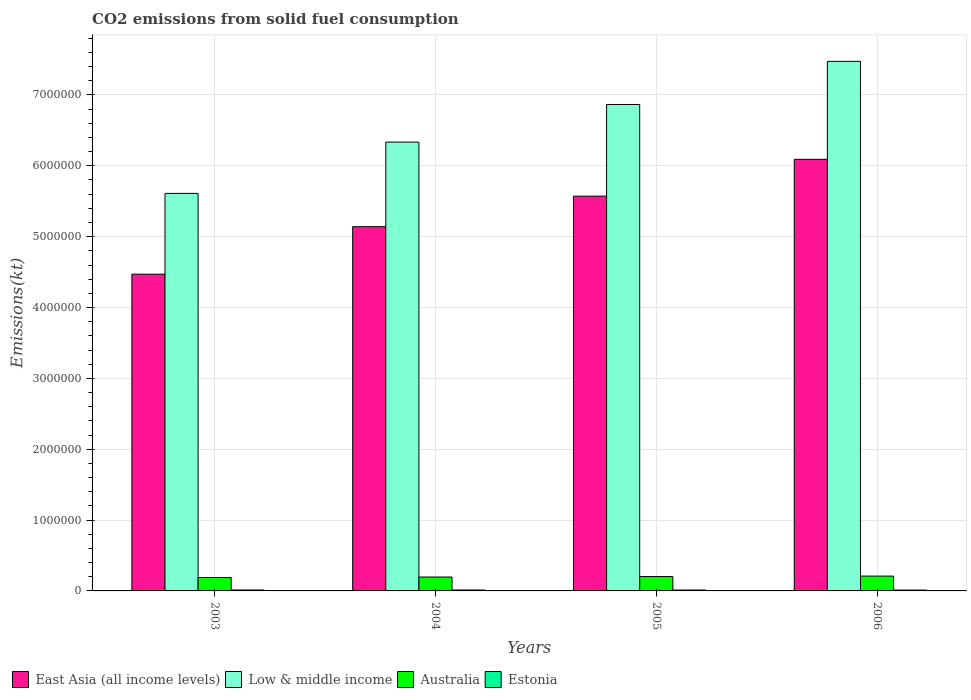How many groups of bars are there?
Your answer should be compact. 4. How many bars are there on the 1st tick from the left?
Offer a terse response. 4. How many bars are there on the 2nd tick from the right?
Make the answer very short. 4. What is the label of the 1st group of bars from the left?
Provide a succinct answer. 2003. What is the amount of CO2 emitted in East Asia (all income levels) in 2005?
Make the answer very short. 5.57e+06. Across all years, what is the maximum amount of CO2 emitted in Australia?
Provide a short and direct response. 2.09e+05. Across all years, what is the minimum amount of CO2 emitted in East Asia (all income levels)?
Offer a terse response. 4.47e+06. In which year was the amount of CO2 emitted in East Asia (all income levels) minimum?
Keep it short and to the point. 2003. What is the total amount of CO2 emitted in Australia in the graph?
Provide a short and direct response. 7.98e+05. What is the difference between the amount of CO2 emitted in Estonia in 2004 and that in 2005?
Your answer should be compact. 498.71. What is the difference between the amount of CO2 emitted in Low & middle income in 2006 and the amount of CO2 emitted in Australia in 2004?
Offer a very short reply. 7.28e+06. What is the average amount of CO2 emitted in Australia per year?
Give a very brief answer. 2.00e+05. In the year 2005, what is the difference between the amount of CO2 emitted in Low & middle income and amount of CO2 emitted in East Asia (all income levels)?
Your answer should be compact. 1.29e+06. In how many years, is the amount of CO2 emitted in East Asia (all income levels) greater than 2400000 kt?
Your answer should be compact. 4. What is the ratio of the amount of CO2 emitted in Australia in 2003 to that in 2006?
Keep it short and to the point. 0.9. Is the amount of CO2 emitted in Estonia in 2003 less than that in 2004?
Provide a short and direct response. Yes. What is the difference between the highest and the second highest amount of CO2 emitted in Australia?
Provide a succinct answer. 6648.27. What is the difference between the highest and the lowest amount of CO2 emitted in Low & middle income?
Your answer should be very brief. 1.86e+06. In how many years, is the amount of CO2 emitted in East Asia (all income levels) greater than the average amount of CO2 emitted in East Asia (all income levels) taken over all years?
Ensure brevity in your answer.  2. What does the 4th bar from the left in 2005 represents?
Ensure brevity in your answer.  Estonia. What does the 4th bar from the right in 2006 represents?
Your response must be concise. East Asia (all income levels). Is it the case that in every year, the sum of the amount of CO2 emitted in East Asia (all income levels) and amount of CO2 emitted in Australia is greater than the amount of CO2 emitted in Estonia?
Provide a succinct answer. Yes. How many bars are there?
Your answer should be very brief. 16. Does the graph contain grids?
Your answer should be compact. Yes. Where does the legend appear in the graph?
Offer a terse response. Bottom left. What is the title of the graph?
Provide a succinct answer. CO2 emissions from solid fuel consumption. Does "Middle income" appear as one of the legend labels in the graph?
Provide a succinct answer. No. What is the label or title of the X-axis?
Give a very brief answer. Years. What is the label or title of the Y-axis?
Keep it short and to the point. Emissions(kt). What is the Emissions(kt) of East Asia (all income levels) in 2003?
Make the answer very short. 4.47e+06. What is the Emissions(kt) of Low & middle income in 2003?
Your answer should be compact. 5.61e+06. What is the Emissions(kt) in Australia in 2003?
Give a very brief answer. 1.90e+05. What is the Emissions(kt) of Estonia in 2003?
Ensure brevity in your answer.  1.31e+04. What is the Emissions(kt) in East Asia (all income levels) in 2004?
Your response must be concise. 5.14e+06. What is the Emissions(kt) of Low & middle income in 2004?
Make the answer very short. 6.33e+06. What is the Emissions(kt) in Australia in 2004?
Provide a short and direct response. 1.96e+05. What is the Emissions(kt) in Estonia in 2004?
Provide a succinct answer. 1.31e+04. What is the Emissions(kt) in East Asia (all income levels) in 2005?
Offer a very short reply. 5.57e+06. What is the Emissions(kt) of Low & middle income in 2005?
Keep it short and to the point. 6.87e+06. What is the Emissions(kt) in Australia in 2005?
Give a very brief answer. 2.03e+05. What is the Emissions(kt) of Estonia in 2005?
Keep it short and to the point. 1.26e+04. What is the Emissions(kt) in East Asia (all income levels) in 2006?
Your response must be concise. 6.09e+06. What is the Emissions(kt) in Low & middle income in 2006?
Offer a very short reply. 7.47e+06. What is the Emissions(kt) of Australia in 2006?
Your answer should be compact. 2.09e+05. What is the Emissions(kt) in Estonia in 2006?
Offer a terse response. 1.20e+04. Across all years, what is the maximum Emissions(kt) in East Asia (all income levels)?
Your response must be concise. 6.09e+06. Across all years, what is the maximum Emissions(kt) in Low & middle income?
Your answer should be very brief. 7.47e+06. Across all years, what is the maximum Emissions(kt) of Australia?
Make the answer very short. 2.09e+05. Across all years, what is the maximum Emissions(kt) of Estonia?
Provide a succinct answer. 1.31e+04. Across all years, what is the minimum Emissions(kt) in East Asia (all income levels)?
Your response must be concise. 4.47e+06. Across all years, what is the minimum Emissions(kt) in Low & middle income?
Offer a terse response. 5.61e+06. Across all years, what is the minimum Emissions(kt) in Australia?
Your answer should be compact. 1.90e+05. Across all years, what is the minimum Emissions(kt) in Estonia?
Your answer should be compact. 1.20e+04. What is the total Emissions(kt) in East Asia (all income levels) in the graph?
Your answer should be compact. 2.13e+07. What is the total Emissions(kt) of Low & middle income in the graph?
Offer a terse response. 2.63e+07. What is the total Emissions(kt) of Australia in the graph?
Your answer should be very brief. 7.98e+05. What is the total Emissions(kt) in Estonia in the graph?
Offer a terse response. 5.09e+04. What is the difference between the Emissions(kt) of East Asia (all income levels) in 2003 and that in 2004?
Offer a terse response. -6.71e+05. What is the difference between the Emissions(kt) in Low & middle income in 2003 and that in 2004?
Provide a succinct answer. -7.24e+05. What is the difference between the Emissions(kt) of Australia in 2003 and that in 2004?
Provide a succinct answer. -6725.28. What is the difference between the Emissions(kt) in Estonia in 2003 and that in 2004?
Your answer should be very brief. -11. What is the difference between the Emissions(kt) of East Asia (all income levels) in 2003 and that in 2005?
Your response must be concise. -1.10e+06. What is the difference between the Emissions(kt) of Low & middle income in 2003 and that in 2005?
Your answer should be compact. -1.26e+06. What is the difference between the Emissions(kt) in Australia in 2003 and that in 2005?
Provide a short and direct response. -1.33e+04. What is the difference between the Emissions(kt) of Estonia in 2003 and that in 2005?
Give a very brief answer. 487.71. What is the difference between the Emissions(kt) in East Asia (all income levels) in 2003 and that in 2006?
Give a very brief answer. -1.62e+06. What is the difference between the Emissions(kt) in Low & middle income in 2003 and that in 2006?
Ensure brevity in your answer.  -1.86e+06. What is the difference between the Emissions(kt) in Australia in 2003 and that in 2006?
Offer a terse response. -2.00e+04. What is the difference between the Emissions(kt) of Estonia in 2003 and that in 2006?
Make the answer very short. 1100.1. What is the difference between the Emissions(kt) of East Asia (all income levels) in 2004 and that in 2005?
Keep it short and to the point. -4.31e+05. What is the difference between the Emissions(kt) in Low & middle income in 2004 and that in 2005?
Make the answer very short. -5.31e+05. What is the difference between the Emissions(kt) of Australia in 2004 and that in 2005?
Offer a terse response. -6578.6. What is the difference between the Emissions(kt) of Estonia in 2004 and that in 2005?
Your answer should be compact. 498.71. What is the difference between the Emissions(kt) of East Asia (all income levels) in 2004 and that in 2006?
Give a very brief answer. -9.51e+05. What is the difference between the Emissions(kt) of Low & middle income in 2004 and that in 2006?
Your answer should be very brief. -1.14e+06. What is the difference between the Emissions(kt) in Australia in 2004 and that in 2006?
Your answer should be very brief. -1.32e+04. What is the difference between the Emissions(kt) of Estonia in 2004 and that in 2006?
Offer a terse response. 1111.1. What is the difference between the Emissions(kt) in East Asia (all income levels) in 2005 and that in 2006?
Offer a terse response. -5.20e+05. What is the difference between the Emissions(kt) in Low & middle income in 2005 and that in 2006?
Offer a terse response. -6.09e+05. What is the difference between the Emissions(kt) of Australia in 2005 and that in 2006?
Offer a terse response. -6648.27. What is the difference between the Emissions(kt) in Estonia in 2005 and that in 2006?
Your answer should be compact. 612.39. What is the difference between the Emissions(kt) in East Asia (all income levels) in 2003 and the Emissions(kt) in Low & middle income in 2004?
Make the answer very short. -1.86e+06. What is the difference between the Emissions(kt) in East Asia (all income levels) in 2003 and the Emissions(kt) in Australia in 2004?
Keep it short and to the point. 4.27e+06. What is the difference between the Emissions(kt) in East Asia (all income levels) in 2003 and the Emissions(kt) in Estonia in 2004?
Offer a terse response. 4.46e+06. What is the difference between the Emissions(kt) of Low & middle income in 2003 and the Emissions(kt) of Australia in 2004?
Offer a terse response. 5.41e+06. What is the difference between the Emissions(kt) of Low & middle income in 2003 and the Emissions(kt) of Estonia in 2004?
Give a very brief answer. 5.60e+06. What is the difference between the Emissions(kt) of Australia in 2003 and the Emissions(kt) of Estonia in 2004?
Give a very brief answer. 1.76e+05. What is the difference between the Emissions(kt) of East Asia (all income levels) in 2003 and the Emissions(kt) of Low & middle income in 2005?
Your response must be concise. -2.40e+06. What is the difference between the Emissions(kt) in East Asia (all income levels) in 2003 and the Emissions(kt) in Australia in 2005?
Give a very brief answer. 4.27e+06. What is the difference between the Emissions(kt) in East Asia (all income levels) in 2003 and the Emissions(kt) in Estonia in 2005?
Your answer should be compact. 4.46e+06. What is the difference between the Emissions(kt) in Low & middle income in 2003 and the Emissions(kt) in Australia in 2005?
Ensure brevity in your answer.  5.41e+06. What is the difference between the Emissions(kt) in Low & middle income in 2003 and the Emissions(kt) in Estonia in 2005?
Ensure brevity in your answer.  5.60e+06. What is the difference between the Emissions(kt) in Australia in 2003 and the Emissions(kt) in Estonia in 2005?
Your answer should be very brief. 1.77e+05. What is the difference between the Emissions(kt) of East Asia (all income levels) in 2003 and the Emissions(kt) of Low & middle income in 2006?
Provide a succinct answer. -3.00e+06. What is the difference between the Emissions(kt) in East Asia (all income levels) in 2003 and the Emissions(kt) in Australia in 2006?
Your answer should be very brief. 4.26e+06. What is the difference between the Emissions(kt) in East Asia (all income levels) in 2003 and the Emissions(kt) in Estonia in 2006?
Your response must be concise. 4.46e+06. What is the difference between the Emissions(kt) of Low & middle income in 2003 and the Emissions(kt) of Australia in 2006?
Offer a terse response. 5.40e+06. What is the difference between the Emissions(kt) of Low & middle income in 2003 and the Emissions(kt) of Estonia in 2006?
Your answer should be compact. 5.60e+06. What is the difference between the Emissions(kt) of Australia in 2003 and the Emissions(kt) of Estonia in 2006?
Your answer should be very brief. 1.78e+05. What is the difference between the Emissions(kt) in East Asia (all income levels) in 2004 and the Emissions(kt) in Low & middle income in 2005?
Keep it short and to the point. -1.72e+06. What is the difference between the Emissions(kt) of East Asia (all income levels) in 2004 and the Emissions(kt) of Australia in 2005?
Provide a succinct answer. 4.94e+06. What is the difference between the Emissions(kt) of East Asia (all income levels) in 2004 and the Emissions(kt) of Estonia in 2005?
Make the answer very short. 5.13e+06. What is the difference between the Emissions(kt) of Low & middle income in 2004 and the Emissions(kt) of Australia in 2005?
Give a very brief answer. 6.13e+06. What is the difference between the Emissions(kt) in Low & middle income in 2004 and the Emissions(kt) in Estonia in 2005?
Provide a short and direct response. 6.32e+06. What is the difference between the Emissions(kt) in Australia in 2004 and the Emissions(kt) in Estonia in 2005?
Give a very brief answer. 1.84e+05. What is the difference between the Emissions(kt) in East Asia (all income levels) in 2004 and the Emissions(kt) in Low & middle income in 2006?
Your response must be concise. -2.33e+06. What is the difference between the Emissions(kt) in East Asia (all income levels) in 2004 and the Emissions(kt) in Australia in 2006?
Ensure brevity in your answer.  4.93e+06. What is the difference between the Emissions(kt) in East Asia (all income levels) in 2004 and the Emissions(kt) in Estonia in 2006?
Provide a succinct answer. 5.13e+06. What is the difference between the Emissions(kt) of Low & middle income in 2004 and the Emissions(kt) of Australia in 2006?
Ensure brevity in your answer.  6.12e+06. What is the difference between the Emissions(kt) of Low & middle income in 2004 and the Emissions(kt) of Estonia in 2006?
Keep it short and to the point. 6.32e+06. What is the difference between the Emissions(kt) of Australia in 2004 and the Emissions(kt) of Estonia in 2006?
Your answer should be compact. 1.84e+05. What is the difference between the Emissions(kt) of East Asia (all income levels) in 2005 and the Emissions(kt) of Low & middle income in 2006?
Give a very brief answer. -1.90e+06. What is the difference between the Emissions(kt) of East Asia (all income levels) in 2005 and the Emissions(kt) of Australia in 2006?
Provide a succinct answer. 5.36e+06. What is the difference between the Emissions(kt) of East Asia (all income levels) in 2005 and the Emissions(kt) of Estonia in 2006?
Ensure brevity in your answer.  5.56e+06. What is the difference between the Emissions(kt) in Low & middle income in 2005 and the Emissions(kt) in Australia in 2006?
Ensure brevity in your answer.  6.66e+06. What is the difference between the Emissions(kt) of Low & middle income in 2005 and the Emissions(kt) of Estonia in 2006?
Offer a very short reply. 6.85e+06. What is the difference between the Emissions(kt) in Australia in 2005 and the Emissions(kt) in Estonia in 2006?
Your answer should be very brief. 1.91e+05. What is the average Emissions(kt) of East Asia (all income levels) per year?
Provide a short and direct response. 5.32e+06. What is the average Emissions(kt) in Low & middle income per year?
Your answer should be compact. 6.57e+06. What is the average Emissions(kt) of Australia per year?
Keep it short and to the point. 2.00e+05. What is the average Emissions(kt) in Estonia per year?
Make the answer very short. 1.27e+04. In the year 2003, what is the difference between the Emissions(kt) in East Asia (all income levels) and Emissions(kt) in Low & middle income?
Your response must be concise. -1.14e+06. In the year 2003, what is the difference between the Emissions(kt) of East Asia (all income levels) and Emissions(kt) of Australia?
Give a very brief answer. 4.28e+06. In the year 2003, what is the difference between the Emissions(kt) in East Asia (all income levels) and Emissions(kt) in Estonia?
Give a very brief answer. 4.46e+06. In the year 2003, what is the difference between the Emissions(kt) in Low & middle income and Emissions(kt) in Australia?
Ensure brevity in your answer.  5.42e+06. In the year 2003, what is the difference between the Emissions(kt) of Low & middle income and Emissions(kt) of Estonia?
Your response must be concise. 5.60e+06. In the year 2003, what is the difference between the Emissions(kt) of Australia and Emissions(kt) of Estonia?
Your response must be concise. 1.76e+05. In the year 2004, what is the difference between the Emissions(kt) of East Asia (all income levels) and Emissions(kt) of Low & middle income?
Your answer should be very brief. -1.19e+06. In the year 2004, what is the difference between the Emissions(kt) of East Asia (all income levels) and Emissions(kt) of Australia?
Your response must be concise. 4.94e+06. In the year 2004, what is the difference between the Emissions(kt) in East Asia (all income levels) and Emissions(kt) in Estonia?
Ensure brevity in your answer.  5.13e+06. In the year 2004, what is the difference between the Emissions(kt) of Low & middle income and Emissions(kt) of Australia?
Your response must be concise. 6.14e+06. In the year 2004, what is the difference between the Emissions(kt) in Low & middle income and Emissions(kt) in Estonia?
Offer a terse response. 6.32e+06. In the year 2004, what is the difference between the Emissions(kt) of Australia and Emissions(kt) of Estonia?
Offer a terse response. 1.83e+05. In the year 2005, what is the difference between the Emissions(kt) in East Asia (all income levels) and Emissions(kt) in Low & middle income?
Your answer should be compact. -1.29e+06. In the year 2005, what is the difference between the Emissions(kt) in East Asia (all income levels) and Emissions(kt) in Australia?
Make the answer very short. 5.37e+06. In the year 2005, what is the difference between the Emissions(kt) in East Asia (all income levels) and Emissions(kt) in Estonia?
Keep it short and to the point. 5.56e+06. In the year 2005, what is the difference between the Emissions(kt) in Low & middle income and Emissions(kt) in Australia?
Provide a short and direct response. 6.66e+06. In the year 2005, what is the difference between the Emissions(kt) in Low & middle income and Emissions(kt) in Estonia?
Provide a succinct answer. 6.85e+06. In the year 2005, what is the difference between the Emissions(kt) of Australia and Emissions(kt) of Estonia?
Provide a succinct answer. 1.90e+05. In the year 2006, what is the difference between the Emissions(kt) of East Asia (all income levels) and Emissions(kt) of Low & middle income?
Give a very brief answer. -1.38e+06. In the year 2006, what is the difference between the Emissions(kt) in East Asia (all income levels) and Emissions(kt) in Australia?
Ensure brevity in your answer.  5.88e+06. In the year 2006, what is the difference between the Emissions(kt) in East Asia (all income levels) and Emissions(kt) in Estonia?
Provide a succinct answer. 6.08e+06. In the year 2006, what is the difference between the Emissions(kt) of Low & middle income and Emissions(kt) of Australia?
Your answer should be very brief. 7.26e+06. In the year 2006, what is the difference between the Emissions(kt) in Low & middle income and Emissions(kt) in Estonia?
Provide a succinct answer. 7.46e+06. In the year 2006, what is the difference between the Emissions(kt) in Australia and Emissions(kt) in Estonia?
Make the answer very short. 1.97e+05. What is the ratio of the Emissions(kt) of East Asia (all income levels) in 2003 to that in 2004?
Your answer should be very brief. 0.87. What is the ratio of the Emissions(kt) in Low & middle income in 2003 to that in 2004?
Ensure brevity in your answer.  0.89. What is the ratio of the Emissions(kt) in Australia in 2003 to that in 2004?
Ensure brevity in your answer.  0.97. What is the ratio of the Emissions(kt) of Estonia in 2003 to that in 2004?
Provide a short and direct response. 1. What is the ratio of the Emissions(kt) in East Asia (all income levels) in 2003 to that in 2005?
Offer a terse response. 0.8. What is the ratio of the Emissions(kt) of Low & middle income in 2003 to that in 2005?
Give a very brief answer. 0.82. What is the ratio of the Emissions(kt) in Australia in 2003 to that in 2005?
Ensure brevity in your answer.  0.93. What is the ratio of the Emissions(kt) in Estonia in 2003 to that in 2005?
Your response must be concise. 1.04. What is the ratio of the Emissions(kt) of East Asia (all income levels) in 2003 to that in 2006?
Make the answer very short. 0.73. What is the ratio of the Emissions(kt) in Low & middle income in 2003 to that in 2006?
Your answer should be very brief. 0.75. What is the ratio of the Emissions(kt) in Australia in 2003 to that in 2006?
Ensure brevity in your answer.  0.9. What is the ratio of the Emissions(kt) of Estonia in 2003 to that in 2006?
Your answer should be compact. 1.09. What is the ratio of the Emissions(kt) of East Asia (all income levels) in 2004 to that in 2005?
Make the answer very short. 0.92. What is the ratio of the Emissions(kt) of Low & middle income in 2004 to that in 2005?
Provide a short and direct response. 0.92. What is the ratio of the Emissions(kt) in Australia in 2004 to that in 2005?
Your answer should be very brief. 0.97. What is the ratio of the Emissions(kt) in Estonia in 2004 to that in 2005?
Your answer should be compact. 1.04. What is the ratio of the Emissions(kt) of East Asia (all income levels) in 2004 to that in 2006?
Your response must be concise. 0.84. What is the ratio of the Emissions(kt) in Low & middle income in 2004 to that in 2006?
Provide a succinct answer. 0.85. What is the ratio of the Emissions(kt) of Australia in 2004 to that in 2006?
Keep it short and to the point. 0.94. What is the ratio of the Emissions(kt) of Estonia in 2004 to that in 2006?
Ensure brevity in your answer.  1.09. What is the ratio of the Emissions(kt) of East Asia (all income levels) in 2005 to that in 2006?
Provide a succinct answer. 0.91. What is the ratio of the Emissions(kt) of Low & middle income in 2005 to that in 2006?
Provide a short and direct response. 0.92. What is the ratio of the Emissions(kt) in Australia in 2005 to that in 2006?
Provide a short and direct response. 0.97. What is the ratio of the Emissions(kt) in Estonia in 2005 to that in 2006?
Keep it short and to the point. 1.05. What is the difference between the highest and the second highest Emissions(kt) of East Asia (all income levels)?
Ensure brevity in your answer.  5.20e+05. What is the difference between the highest and the second highest Emissions(kt) of Low & middle income?
Offer a very short reply. 6.09e+05. What is the difference between the highest and the second highest Emissions(kt) of Australia?
Offer a very short reply. 6648.27. What is the difference between the highest and the second highest Emissions(kt) in Estonia?
Your response must be concise. 11. What is the difference between the highest and the lowest Emissions(kt) in East Asia (all income levels)?
Offer a terse response. 1.62e+06. What is the difference between the highest and the lowest Emissions(kt) of Low & middle income?
Provide a succinct answer. 1.86e+06. What is the difference between the highest and the lowest Emissions(kt) in Australia?
Offer a terse response. 2.00e+04. What is the difference between the highest and the lowest Emissions(kt) in Estonia?
Offer a terse response. 1111.1. 